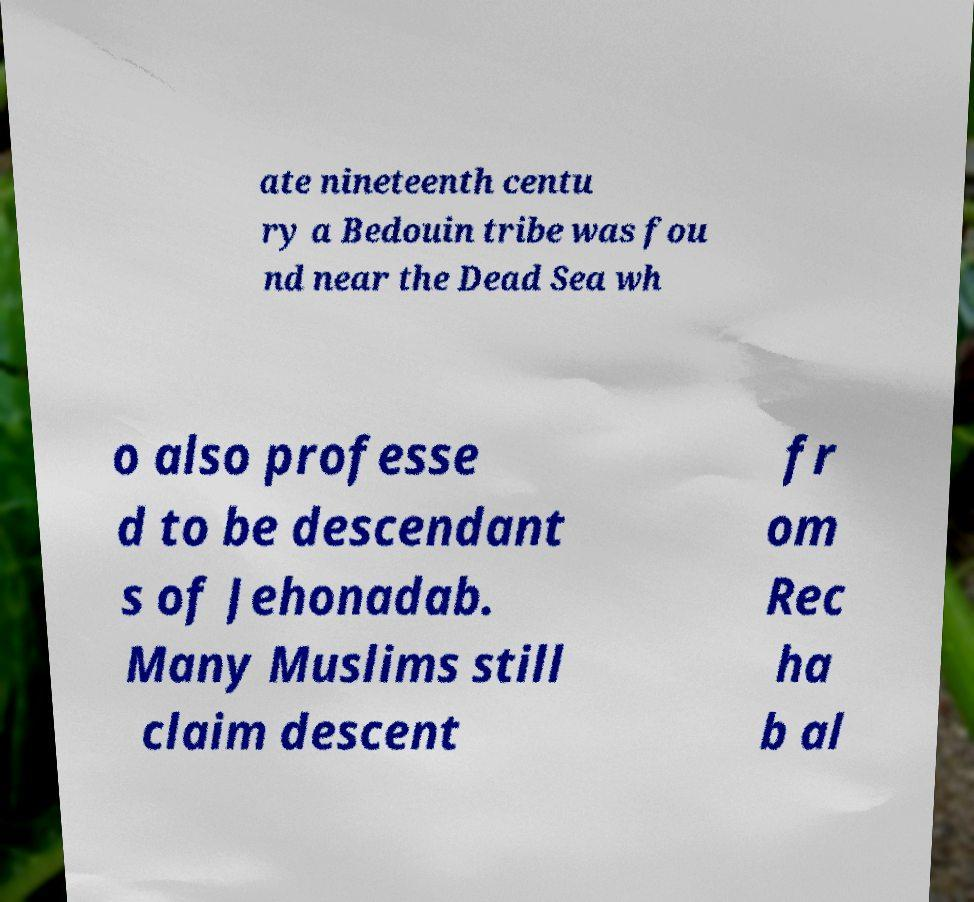Could you assist in decoding the text presented in this image and type it out clearly? ate nineteenth centu ry a Bedouin tribe was fou nd near the Dead Sea wh o also professe d to be descendant s of Jehonadab. Many Muslims still claim descent fr om Rec ha b al 